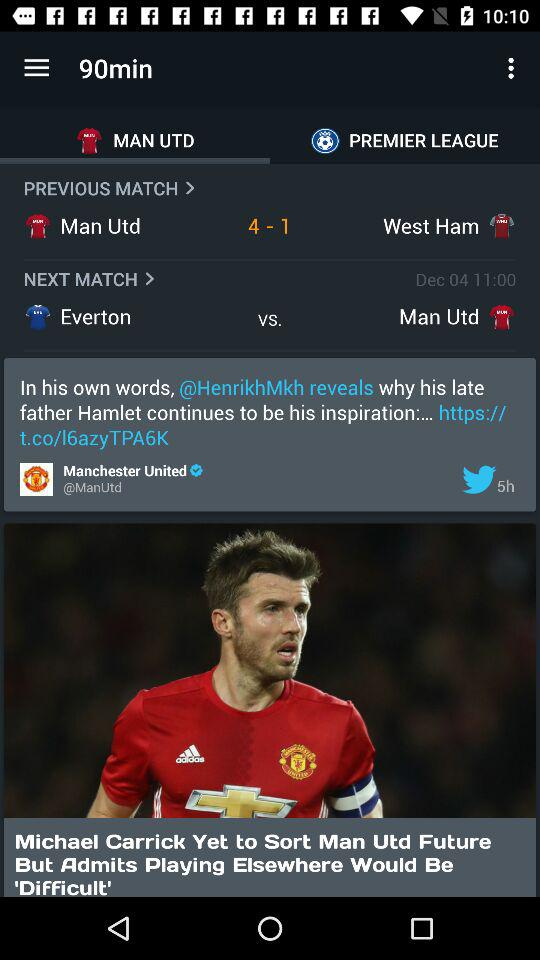How many more goals did Man Utd score than West Ham?
Answer the question using a single word or phrase. 3 